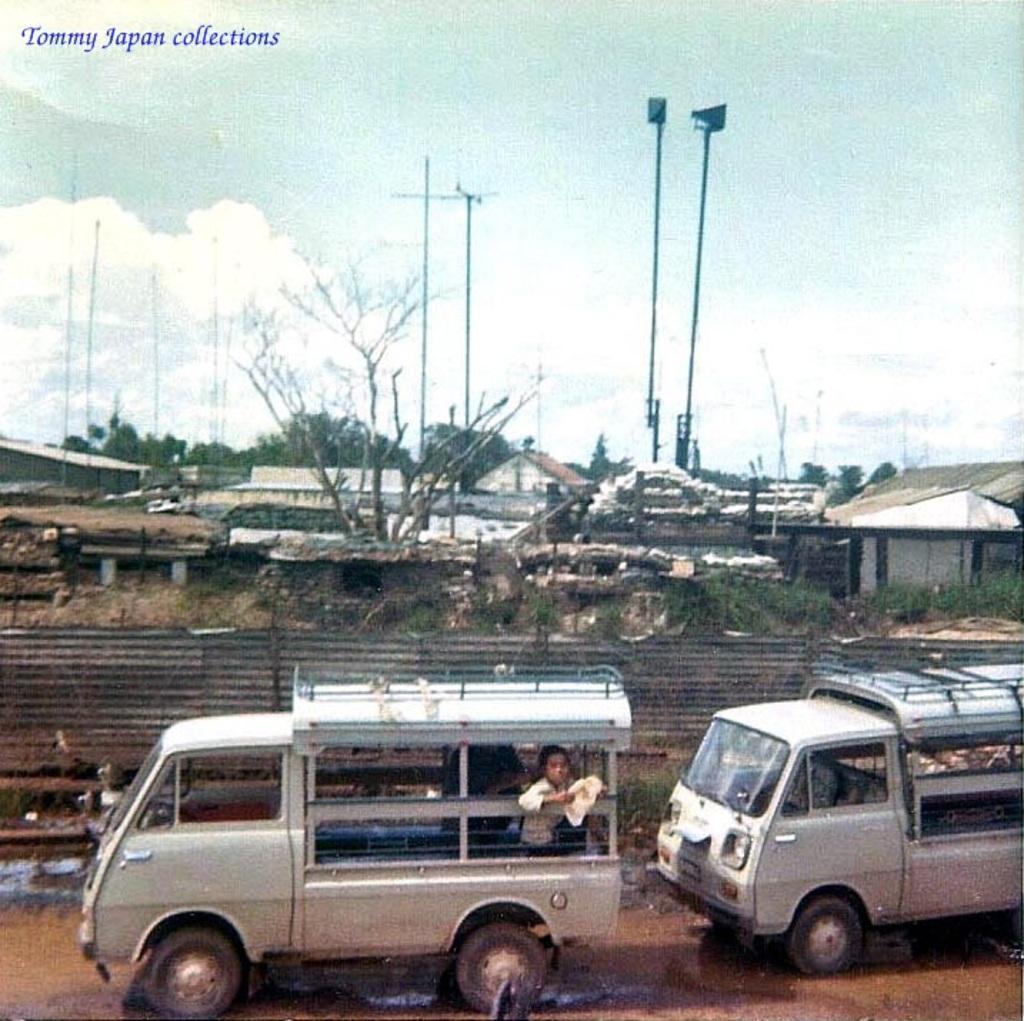In one or two sentences, can you explain what this image depicts? In this image I can see the vehicles on the road. These vehicles are in white color and I can see one person in the vehicle. To the side there is a railing. In the back there are many trees, houses and the poles. I can also see the clouds and the sky in the back. 